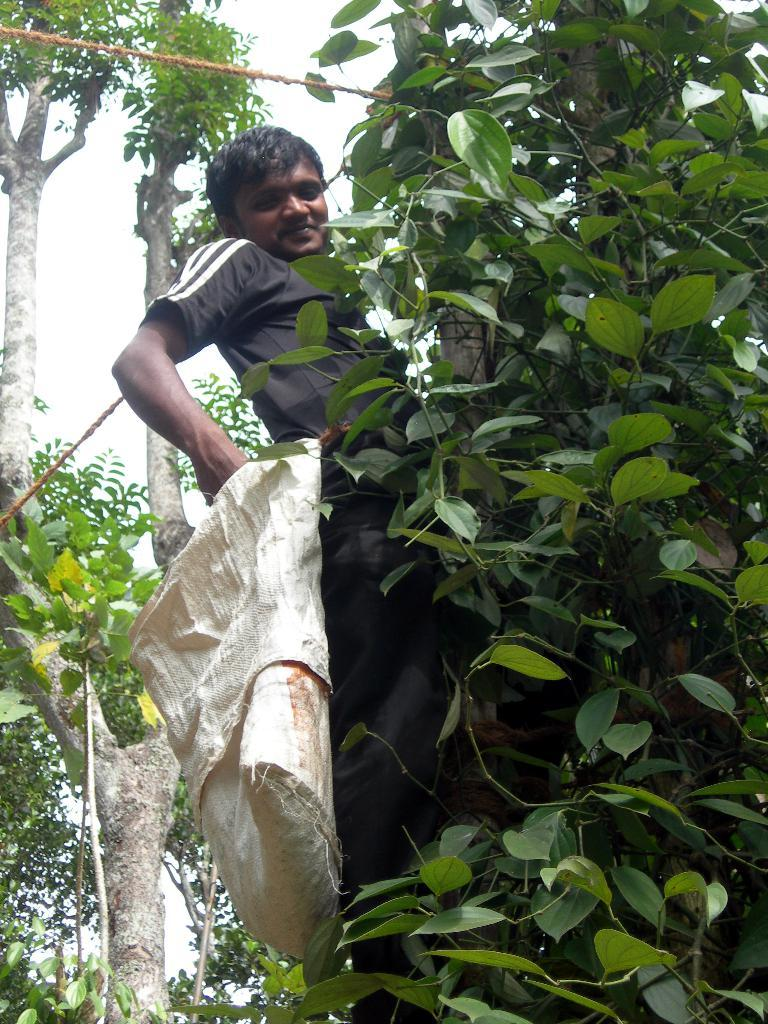What types of vegetation are in the foreground of the picture? There are trees and shrubs in the foreground of the picture. What is the person in the picture doing? The person is on one of the trees. What is the son saying in the picture? There is no son or any voice present in the picture; it only shows trees, shrubs, and a person on one of the trees. 